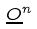<formula> <loc_0><loc_0><loc_500><loc_500>\underline { O } ^ { n }</formula> 